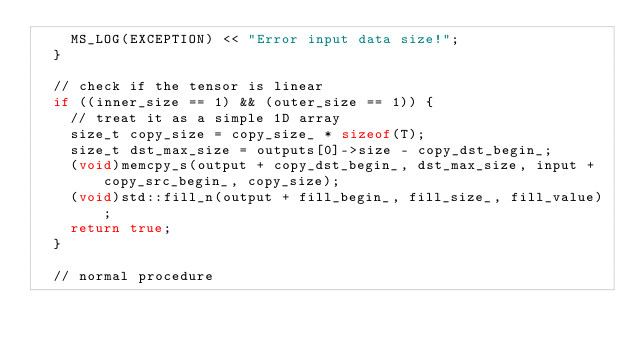<code> <loc_0><loc_0><loc_500><loc_500><_C++_>    MS_LOG(EXCEPTION) << "Error input data size!";
  }

  // check if the tensor is linear
  if ((inner_size == 1) && (outer_size == 1)) {
    // treat it as a simple 1D array
    size_t copy_size = copy_size_ * sizeof(T);
    size_t dst_max_size = outputs[0]->size - copy_dst_begin_;
    (void)memcpy_s(output + copy_dst_begin_, dst_max_size, input + copy_src_begin_, copy_size);
    (void)std::fill_n(output + fill_begin_, fill_size_, fill_value);
    return true;
  }

  // normal procedure</code> 